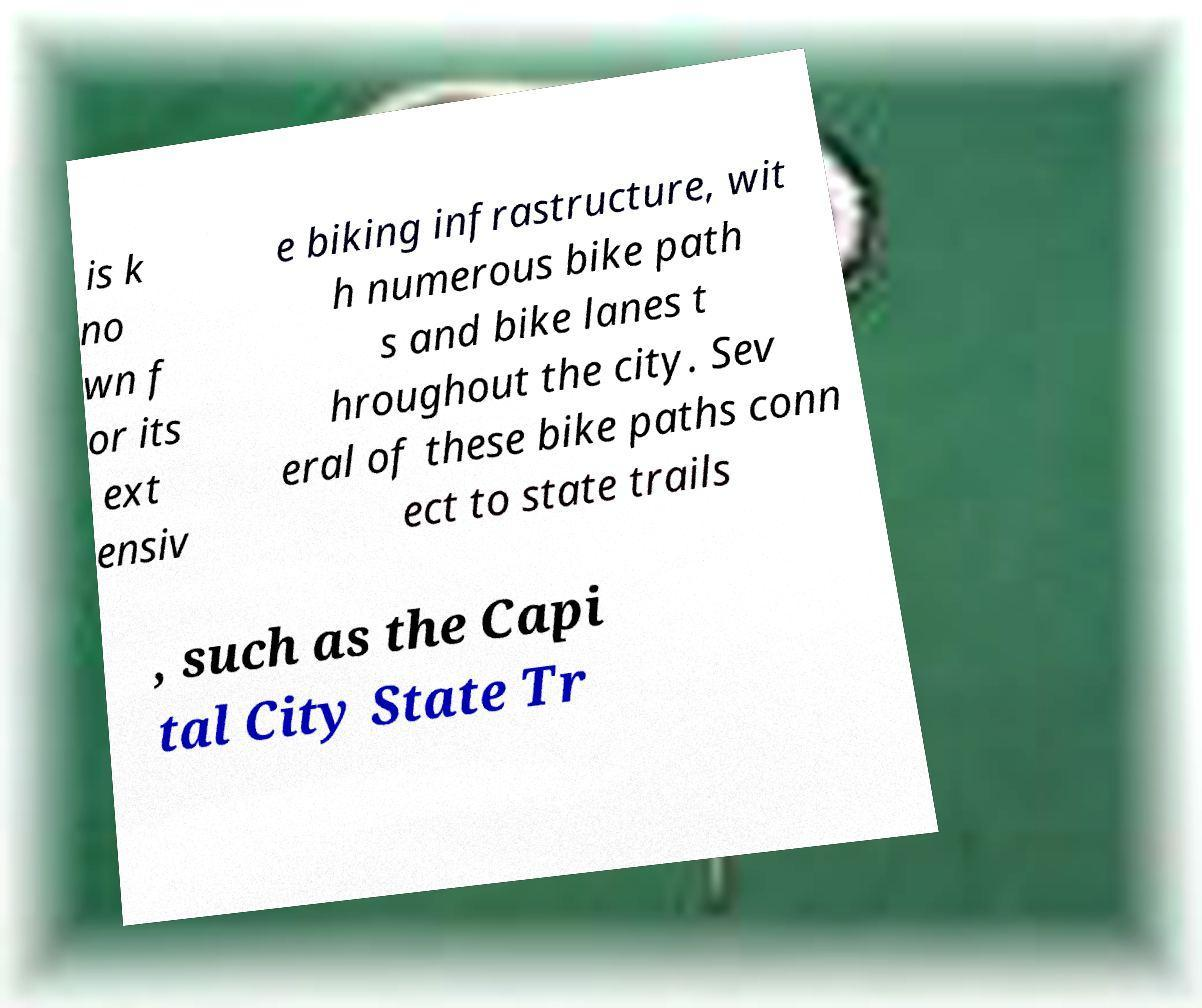Could you assist in decoding the text presented in this image and type it out clearly? is k no wn f or its ext ensiv e biking infrastructure, wit h numerous bike path s and bike lanes t hroughout the city. Sev eral of these bike paths conn ect to state trails , such as the Capi tal City State Tr 